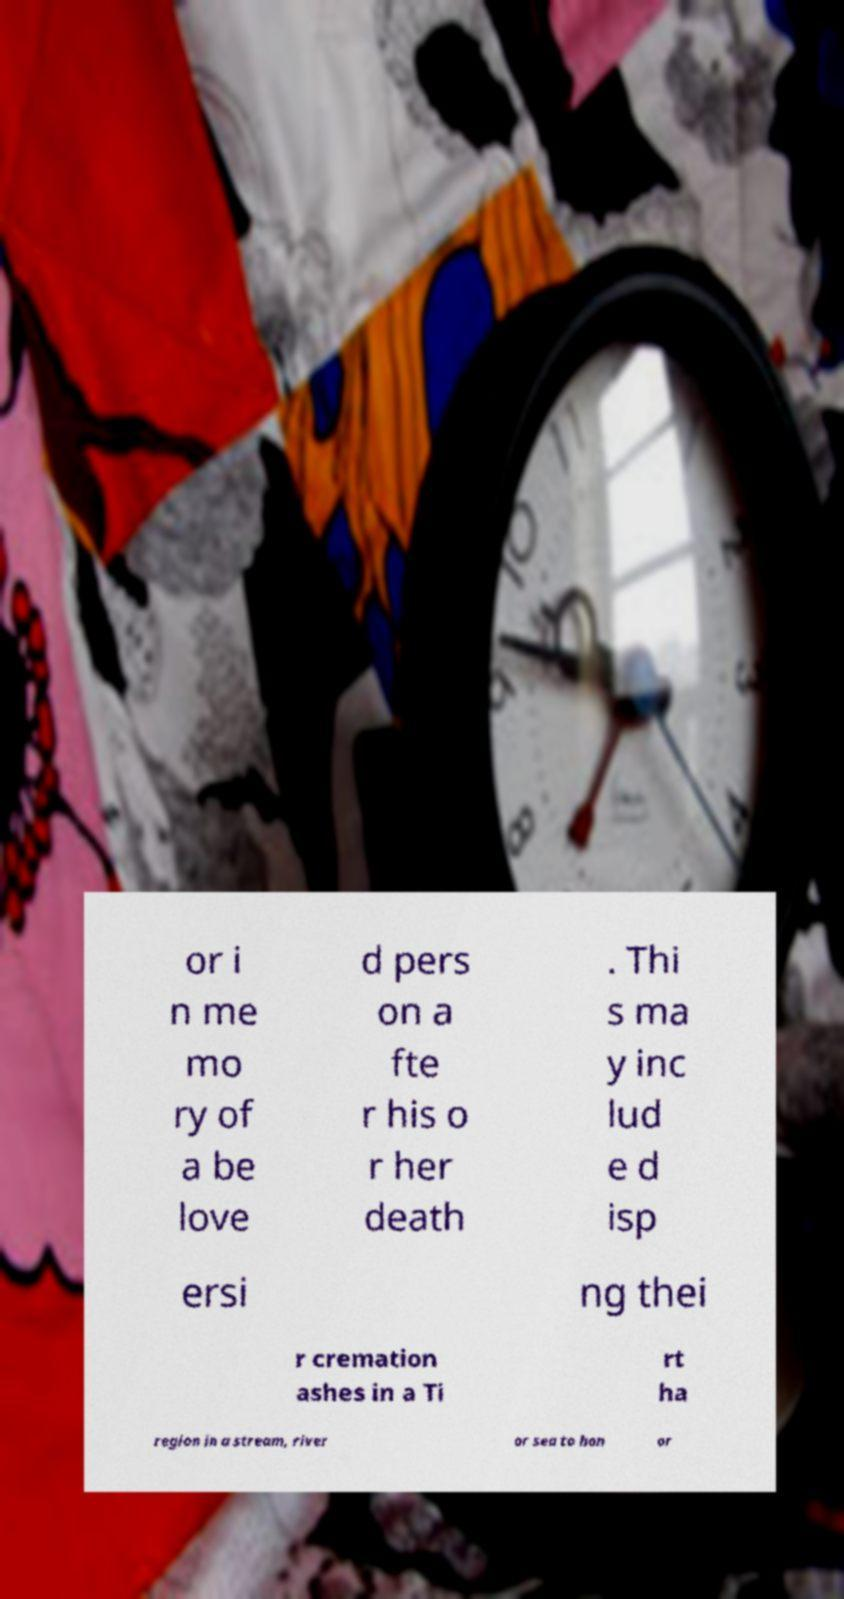Can you accurately transcribe the text from the provided image for me? or i n me mo ry of a be love d pers on a fte r his o r her death . Thi s ma y inc lud e d isp ersi ng thei r cremation ashes in a Ti rt ha region in a stream, river or sea to hon or 